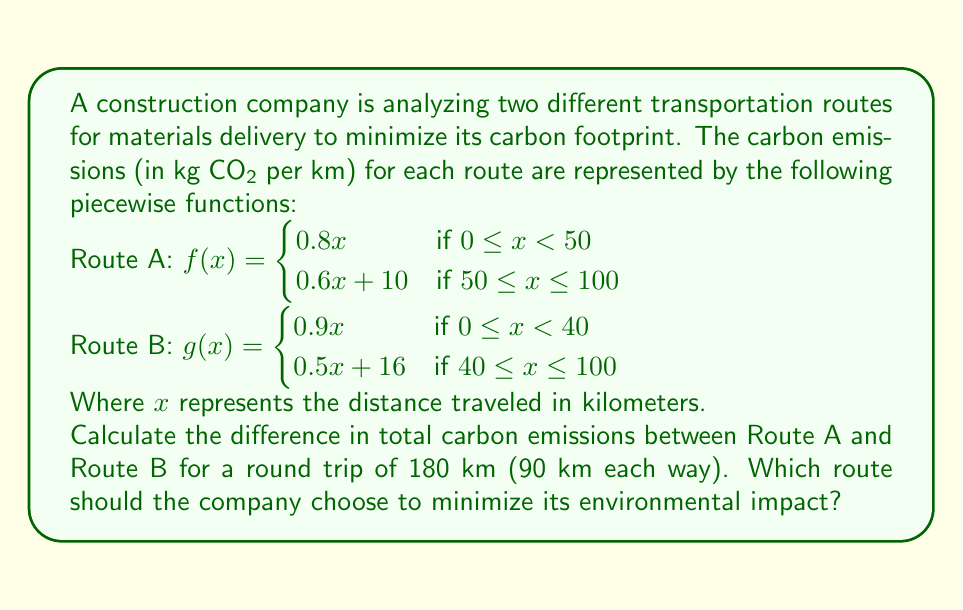Can you answer this question? To solve this problem, we need to calculate the carbon emissions for each route for a 90 km journey (one way) and then double it for the round trip. Let's break it down step by step:

1. Route A emissions:
   For $x = 90$ km, we use the second piece of the function as $90 \geq 50$
   $f(90) = 0.6(90) + 10 = 54 + 10 = 64$ kg CO2

2. Route B emissions:
   For $x = 90$ km, we use the second piece of the function as $90 \geq 40$
   $g(90) = 0.5(90) + 16 = 45 + 16 = 61$ kg CO2

3. Calculate round trip emissions:
   Route A: $64 \times 2 = 128$ kg CO2
   Route B: $61 \times 2 = 122$ kg CO2

4. Calculate the difference in emissions:
   Difference = Route A emissions - Route B emissions
               = $128 - 122 = 6$ kg CO2

Route B produces 6 kg less CO2 for the round trip compared to Route A.
Answer: The difference in total carbon emissions between Route A and Route B for a 180 km round trip is 6 kg CO2. The company should choose Route B to minimize its environmental impact. 